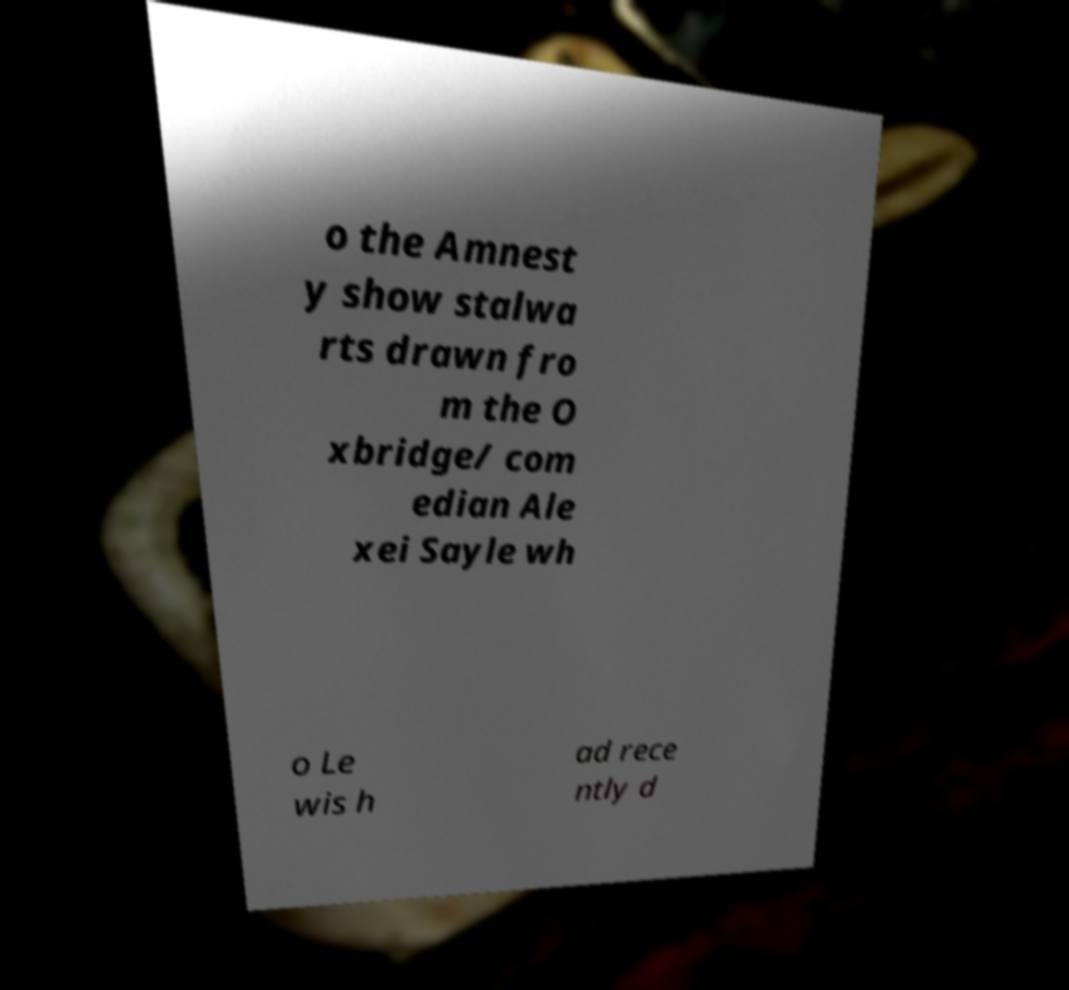Can you accurately transcribe the text from the provided image for me? o the Amnest y show stalwa rts drawn fro m the O xbridge/ com edian Ale xei Sayle wh o Le wis h ad rece ntly d 